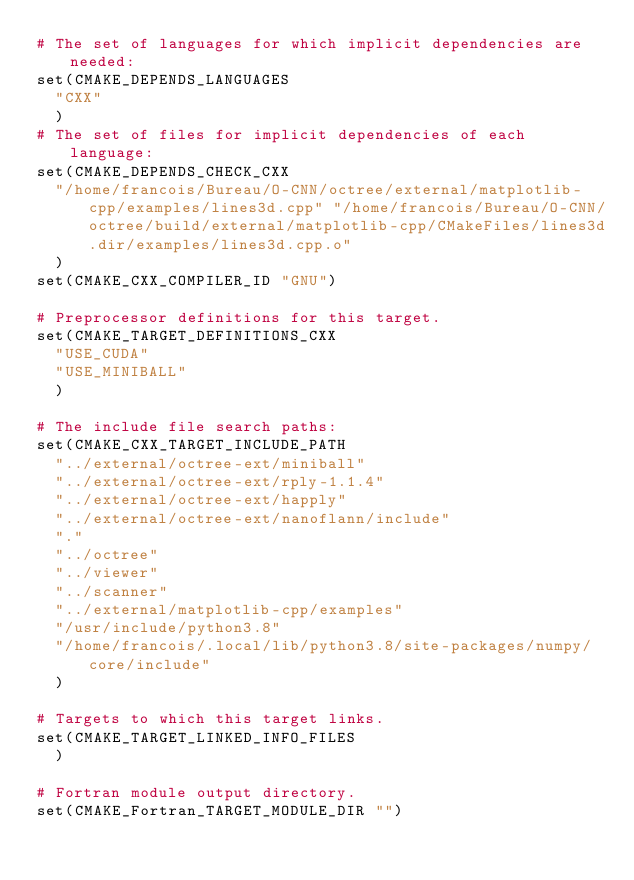<code> <loc_0><loc_0><loc_500><loc_500><_CMake_># The set of languages for which implicit dependencies are needed:
set(CMAKE_DEPENDS_LANGUAGES
  "CXX"
  )
# The set of files for implicit dependencies of each language:
set(CMAKE_DEPENDS_CHECK_CXX
  "/home/francois/Bureau/O-CNN/octree/external/matplotlib-cpp/examples/lines3d.cpp" "/home/francois/Bureau/O-CNN/octree/build/external/matplotlib-cpp/CMakeFiles/lines3d.dir/examples/lines3d.cpp.o"
  )
set(CMAKE_CXX_COMPILER_ID "GNU")

# Preprocessor definitions for this target.
set(CMAKE_TARGET_DEFINITIONS_CXX
  "USE_CUDA"
  "USE_MINIBALL"
  )

# The include file search paths:
set(CMAKE_CXX_TARGET_INCLUDE_PATH
  "../external/octree-ext/miniball"
  "../external/octree-ext/rply-1.1.4"
  "../external/octree-ext/happly"
  "../external/octree-ext/nanoflann/include"
  "."
  "../octree"
  "../viewer"
  "../scanner"
  "../external/matplotlib-cpp/examples"
  "/usr/include/python3.8"
  "/home/francois/.local/lib/python3.8/site-packages/numpy/core/include"
  )

# Targets to which this target links.
set(CMAKE_TARGET_LINKED_INFO_FILES
  )

# Fortran module output directory.
set(CMAKE_Fortran_TARGET_MODULE_DIR "")
</code> 